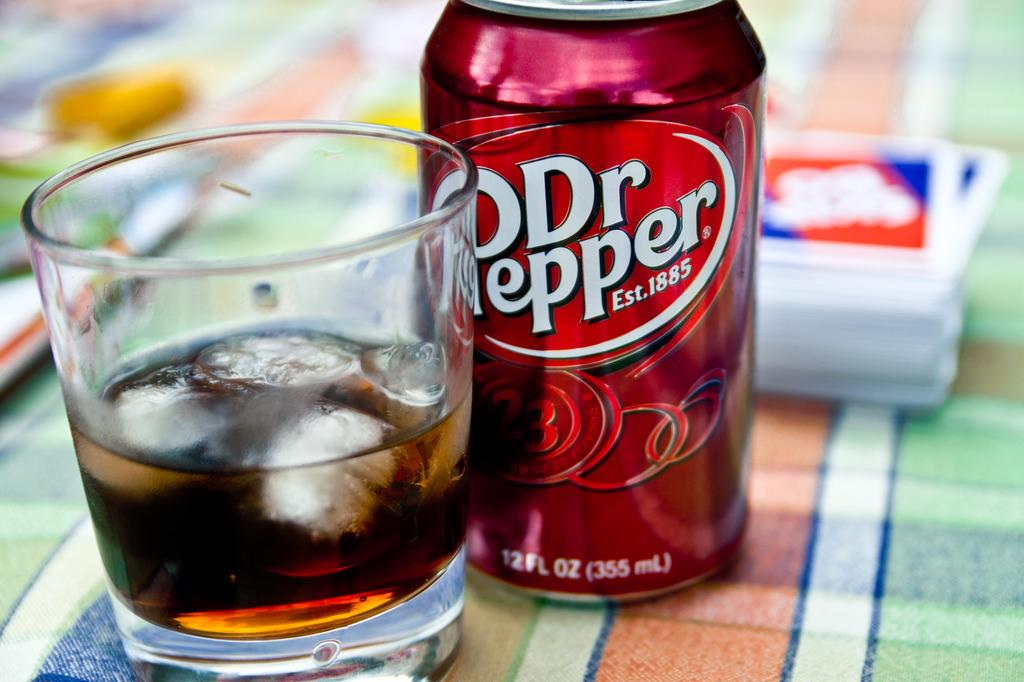<image>
Relay a brief, clear account of the picture shown. A can of Dr Pepper is next to a glass with ice and a drink in it. 